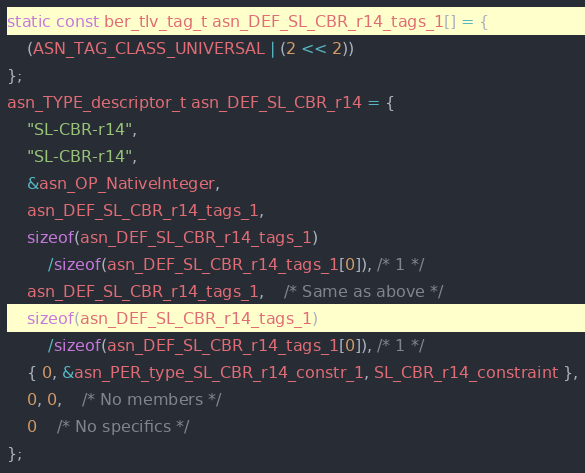<code> <loc_0><loc_0><loc_500><loc_500><_C_>static const ber_tlv_tag_t asn_DEF_SL_CBR_r14_tags_1[] = {
	(ASN_TAG_CLASS_UNIVERSAL | (2 << 2))
};
asn_TYPE_descriptor_t asn_DEF_SL_CBR_r14 = {
	"SL-CBR-r14",
	"SL-CBR-r14",
	&asn_OP_NativeInteger,
	asn_DEF_SL_CBR_r14_tags_1,
	sizeof(asn_DEF_SL_CBR_r14_tags_1)
		/sizeof(asn_DEF_SL_CBR_r14_tags_1[0]), /* 1 */
	asn_DEF_SL_CBR_r14_tags_1,	/* Same as above */
	sizeof(asn_DEF_SL_CBR_r14_tags_1)
		/sizeof(asn_DEF_SL_CBR_r14_tags_1[0]), /* 1 */
	{ 0, &asn_PER_type_SL_CBR_r14_constr_1, SL_CBR_r14_constraint },
	0, 0,	/* No members */
	0	/* No specifics */
};

</code> 